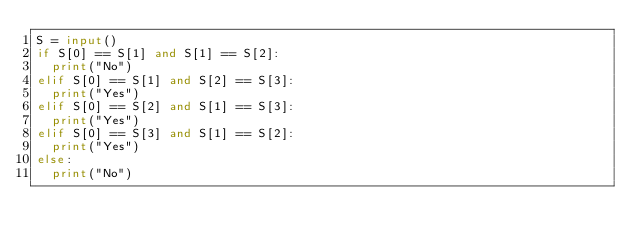Convert code to text. <code><loc_0><loc_0><loc_500><loc_500><_Python_>S = input()
if S[0] == S[1] and S[1] == S[2]:
  print("No")
elif S[0] == S[1] and S[2] == S[3]:
  print("Yes")
elif S[0] == S[2] and S[1] == S[3]:
  print("Yes")
elif S[0] == S[3] and S[1] == S[2]:
  print("Yes")
else:
  print("No")
</code> 